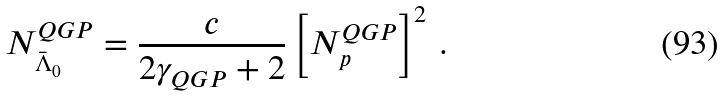Convert formula to latex. <formula><loc_0><loc_0><loc_500><loc_500>N ^ { Q G P } _ { \bar { \Lambda } _ { 0 } } = \frac { c } { 2 \gamma _ { Q G P } + 2 } \left [ N ^ { Q G P } _ { p } \right ] ^ { 2 } \, .</formula> 